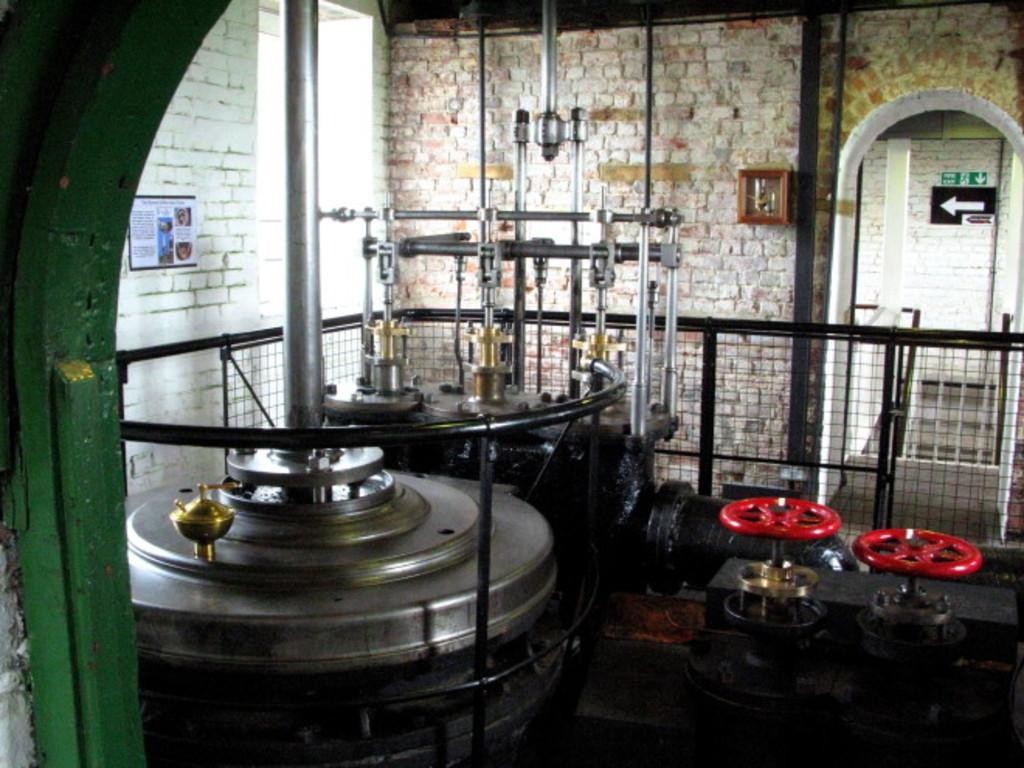Can you describe this image briefly? In this image we can see the machines with the metal poles and the wheels. We can also see a paper and a wooden box on a wall, a metal fence and the sign boards. 